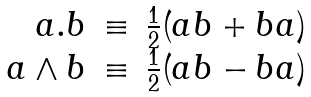Convert formula to latex. <formula><loc_0><loc_0><loc_500><loc_500>\begin{array} { r r r } a . b & \equiv & \frac { 1 } { 2 } ( a b + b a ) \\ a \wedge b & \equiv & \frac { 1 } { 2 } ( a b - b a ) \end{array}</formula> 